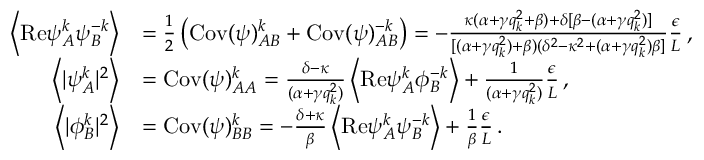Convert formula to latex. <formula><loc_0><loc_0><loc_500><loc_500>\begin{array} { r l } { \left \langle R e { \psi } _ { A } ^ { k } { \psi } _ { B } ^ { - k } \right \rangle } & { = \frac { 1 } { 2 } \left ( C o v ( \psi ) _ { A B } ^ { k } + C o v ( \psi ) _ { A B } ^ { - k } \right ) = - \frac { \kappa ( \alpha + \gamma q _ { k } ^ { 2 } + \beta ) + \delta [ \beta - ( \alpha + \gamma q _ { k } ^ { 2 } ) ] } { [ ( \alpha + \gamma q _ { k } ^ { 2 } ) + \beta ) ( \delta ^ { 2 } - \kappa ^ { 2 } + ( \alpha + \gamma q _ { k } ^ { 2 } ) \beta ] } \frac { \epsilon } { L } \, , } \\ { \left \langle | { \psi } _ { A } ^ { k } | ^ { 2 } \right \rangle } & { = C o v ( \psi ) _ { A A } ^ { k } = \frac { \delta - \kappa } { ( \alpha + \gamma q _ { k } ^ { 2 } ) } \left \langle R e { \psi } _ { A } ^ { k } { \phi } _ { B } ^ { - k } \right \rangle + \frac { 1 } { ( \alpha + \gamma q _ { k } ^ { 2 } ) } \frac { \epsilon } { L } \, , } \\ { \left \langle | { \phi } _ { B } ^ { k } | ^ { 2 } \right \rangle } & { = C o v ( \psi ) _ { B B } ^ { k } = - \frac { \delta + \kappa } { \beta } \left \langle R e { \psi } _ { A } ^ { k } { \psi } _ { B } ^ { - k } \right \rangle + \frac { 1 } { \beta } \frac { \epsilon } { L } \, . } \end{array}</formula> 